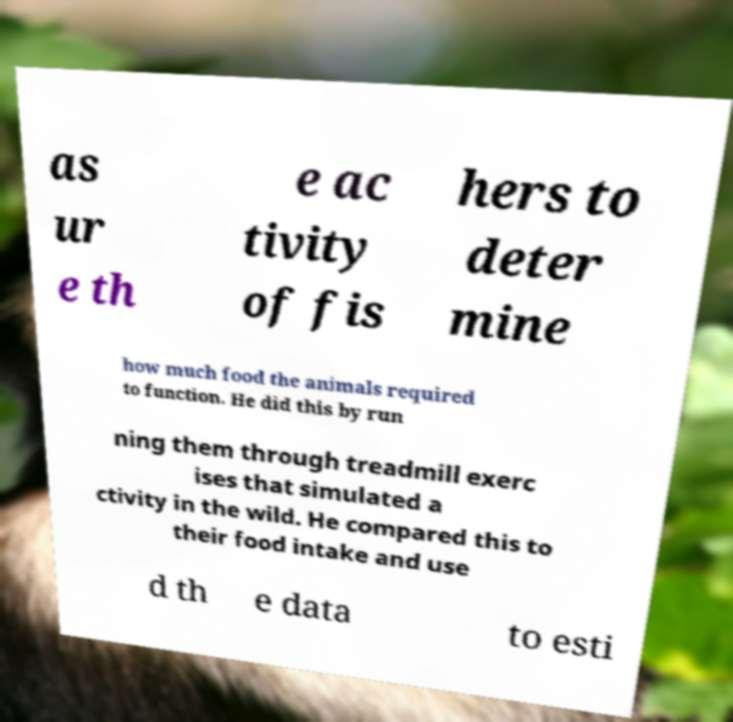There's text embedded in this image that I need extracted. Can you transcribe it verbatim? as ur e th e ac tivity of fis hers to deter mine how much food the animals required to function. He did this by run ning them through treadmill exerc ises that simulated a ctivity in the wild. He compared this to their food intake and use d th e data to esti 